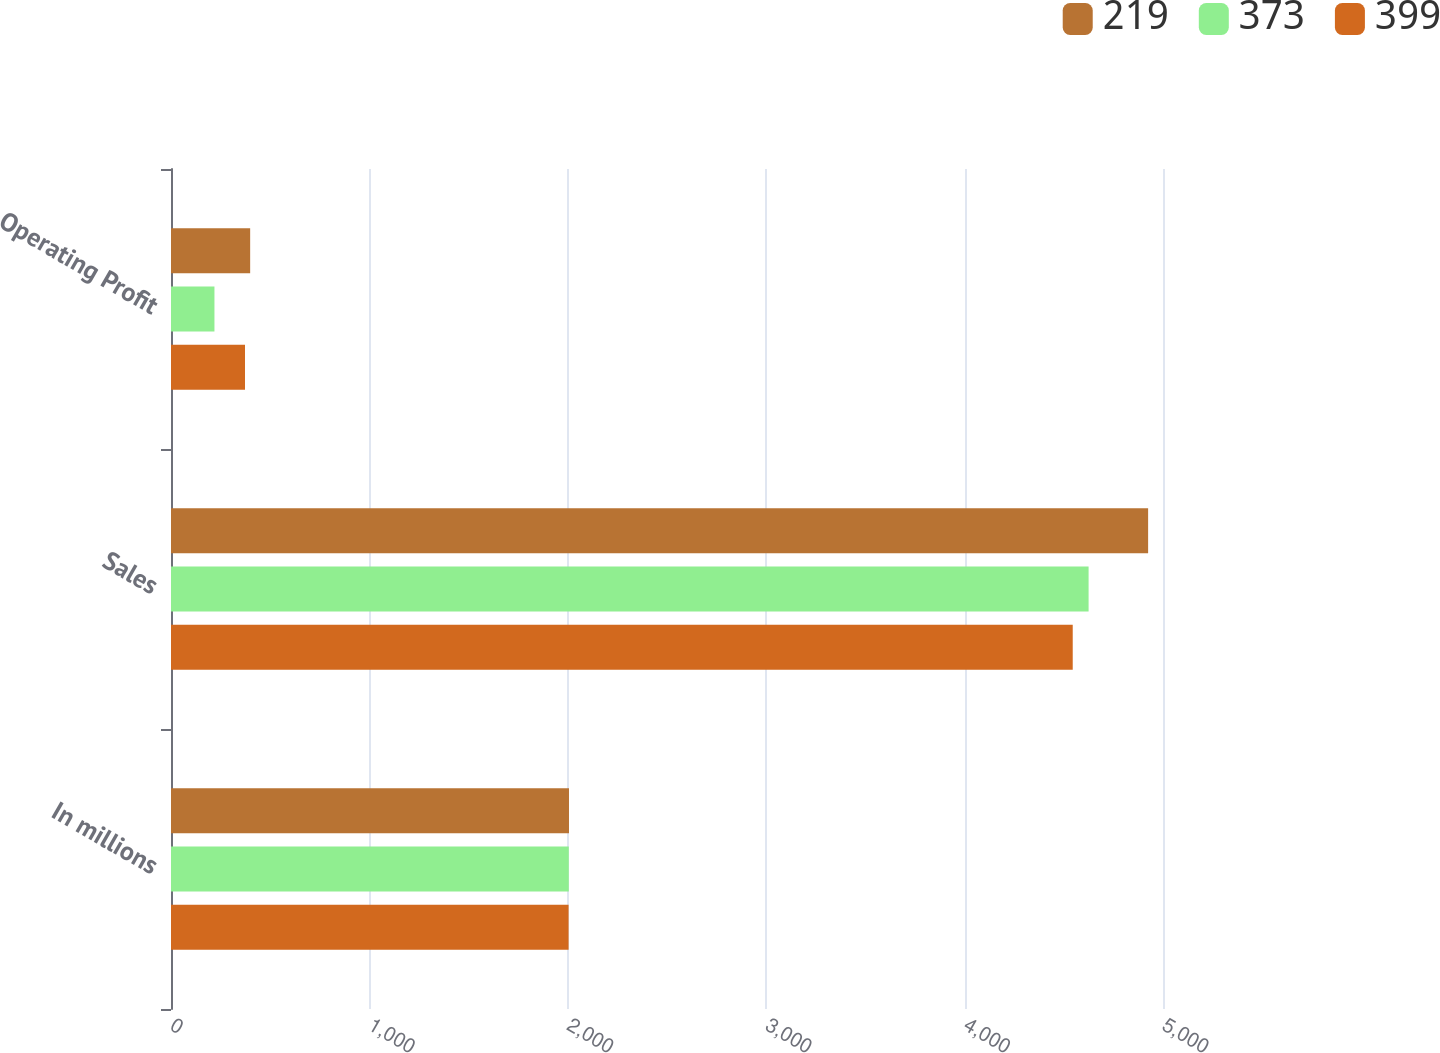Convert chart to OTSL. <chart><loc_0><loc_0><loc_500><loc_500><stacked_bar_chart><ecel><fcel>In millions<fcel>Sales<fcel>Operating Profit<nl><fcel>219<fcel>2006<fcel>4925<fcel>399<nl><fcel>373<fcel>2005<fcel>4625<fcel>219<nl><fcel>399<fcel>2004<fcel>4545<fcel>373<nl></chart> 